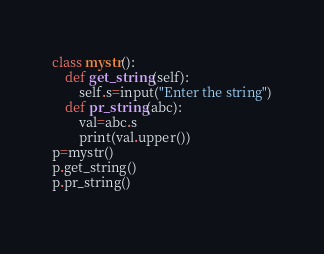Convert code to text. <code><loc_0><loc_0><loc_500><loc_500><_Python_>class mystr():
    def get_string(self):
        self.s=input("Enter the string")
    def pr_string(abc):
        val=abc.s
        print(val.upper())
p=mystr()
p.get_string()
p.pr_string()
        
</code> 